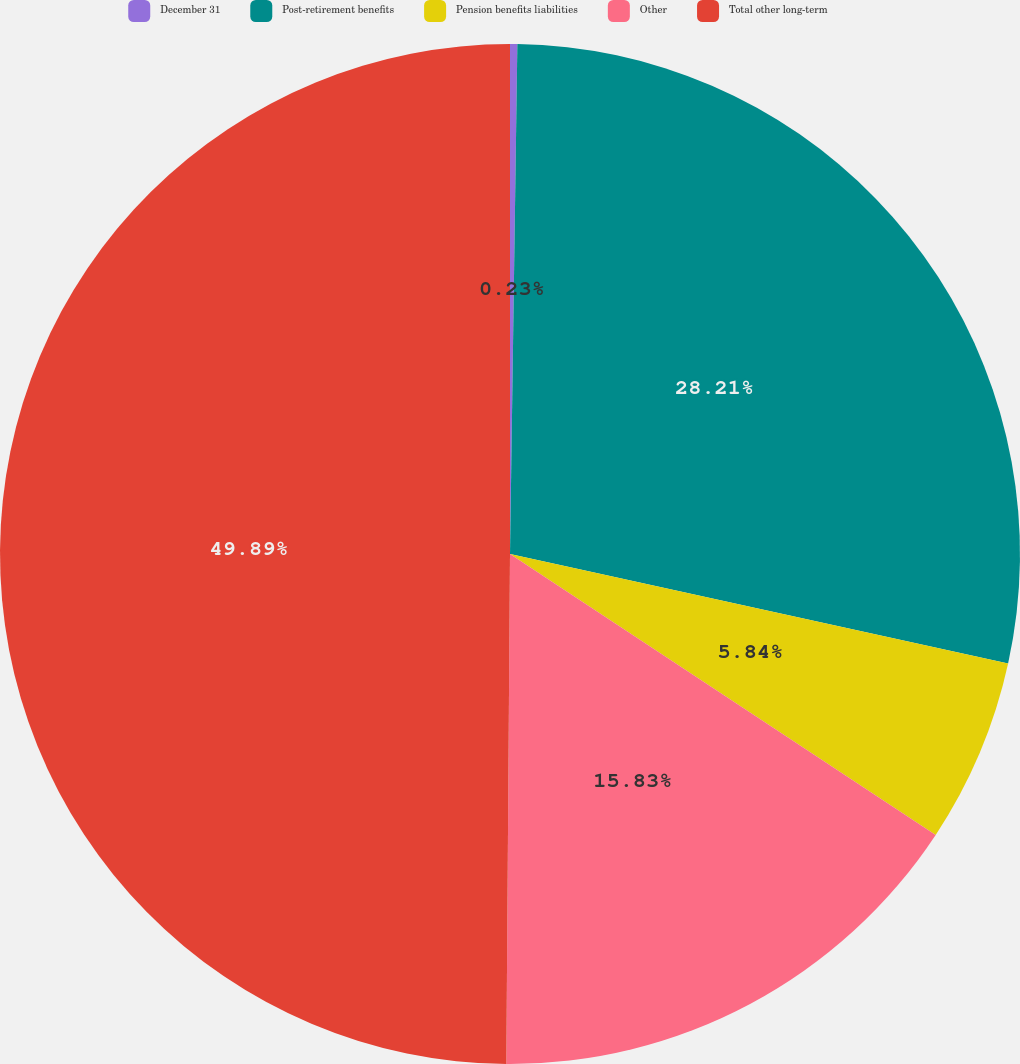Convert chart. <chart><loc_0><loc_0><loc_500><loc_500><pie_chart><fcel>December 31<fcel>Post-retirement benefits<fcel>Pension benefits liabilities<fcel>Other<fcel>Total other long-term<nl><fcel>0.23%<fcel>28.21%<fcel>5.84%<fcel>15.83%<fcel>49.88%<nl></chart> 